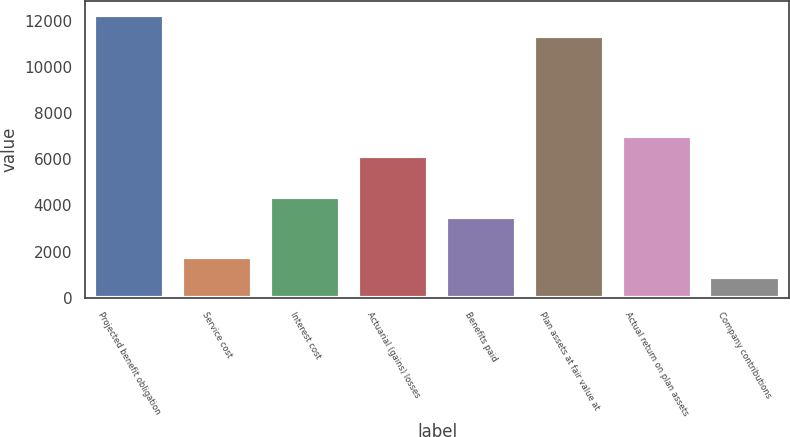Convert chart. <chart><loc_0><loc_0><loc_500><loc_500><bar_chart><fcel>Projected benefit obligation<fcel>Service cost<fcel>Interest cost<fcel>Actuarial (gains) losses<fcel>Benefits paid<fcel>Plan assets at fair value at<fcel>Actual return on plan assets<fcel>Company contributions<nl><fcel>12246<fcel>1764<fcel>4384.5<fcel>6131.5<fcel>3511<fcel>11372.5<fcel>7005<fcel>890.5<nl></chart> 